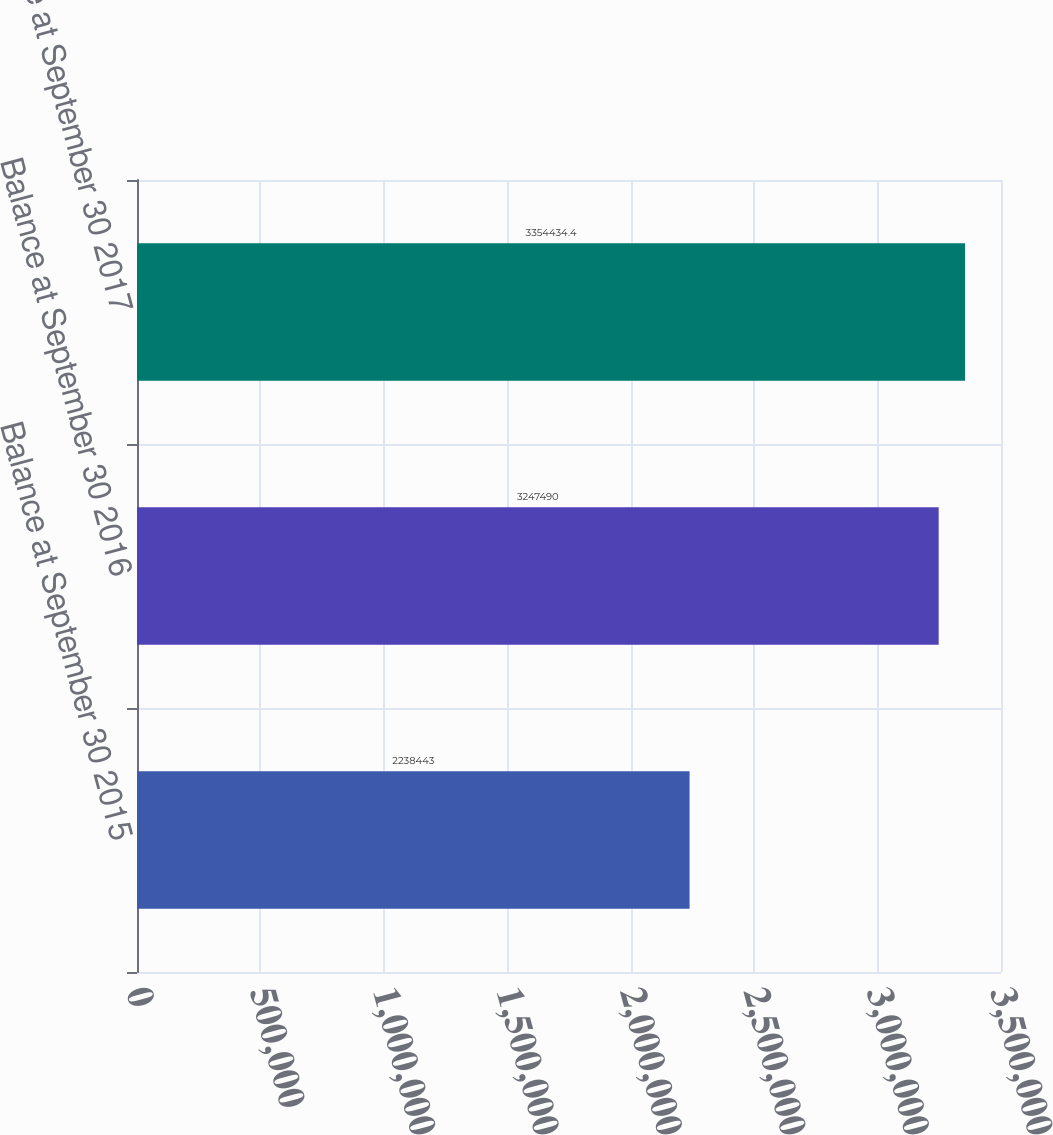Convert chart to OTSL. <chart><loc_0><loc_0><loc_500><loc_500><bar_chart><fcel>Balance at September 30 2015<fcel>Balance at September 30 2016<fcel>Balance at September 30 2017<nl><fcel>2.23844e+06<fcel>3.24749e+06<fcel>3.35443e+06<nl></chart> 